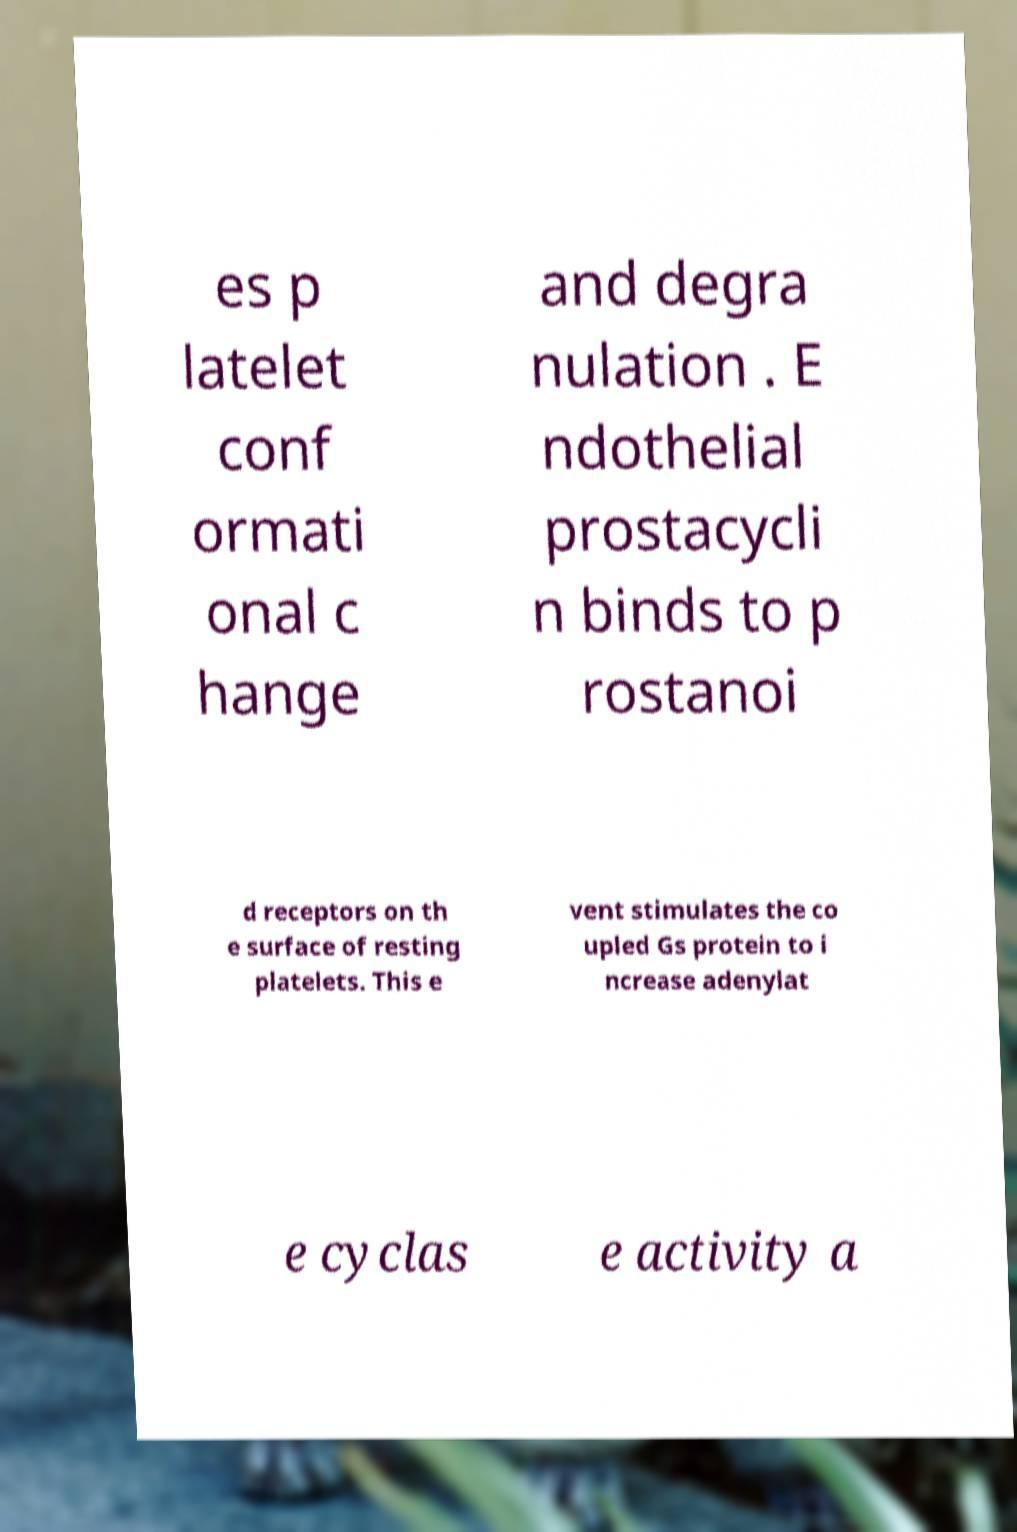There's text embedded in this image that I need extracted. Can you transcribe it verbatim? es p latelet conf ormati onal c hange and degra nulation . E ndothelial prostacycli n binds to p rostanoi d receptors on th e surface of resting platelets. This e vent stimulates the co upled Gs protein to i ncrease adenylat e cyclas e activity a 